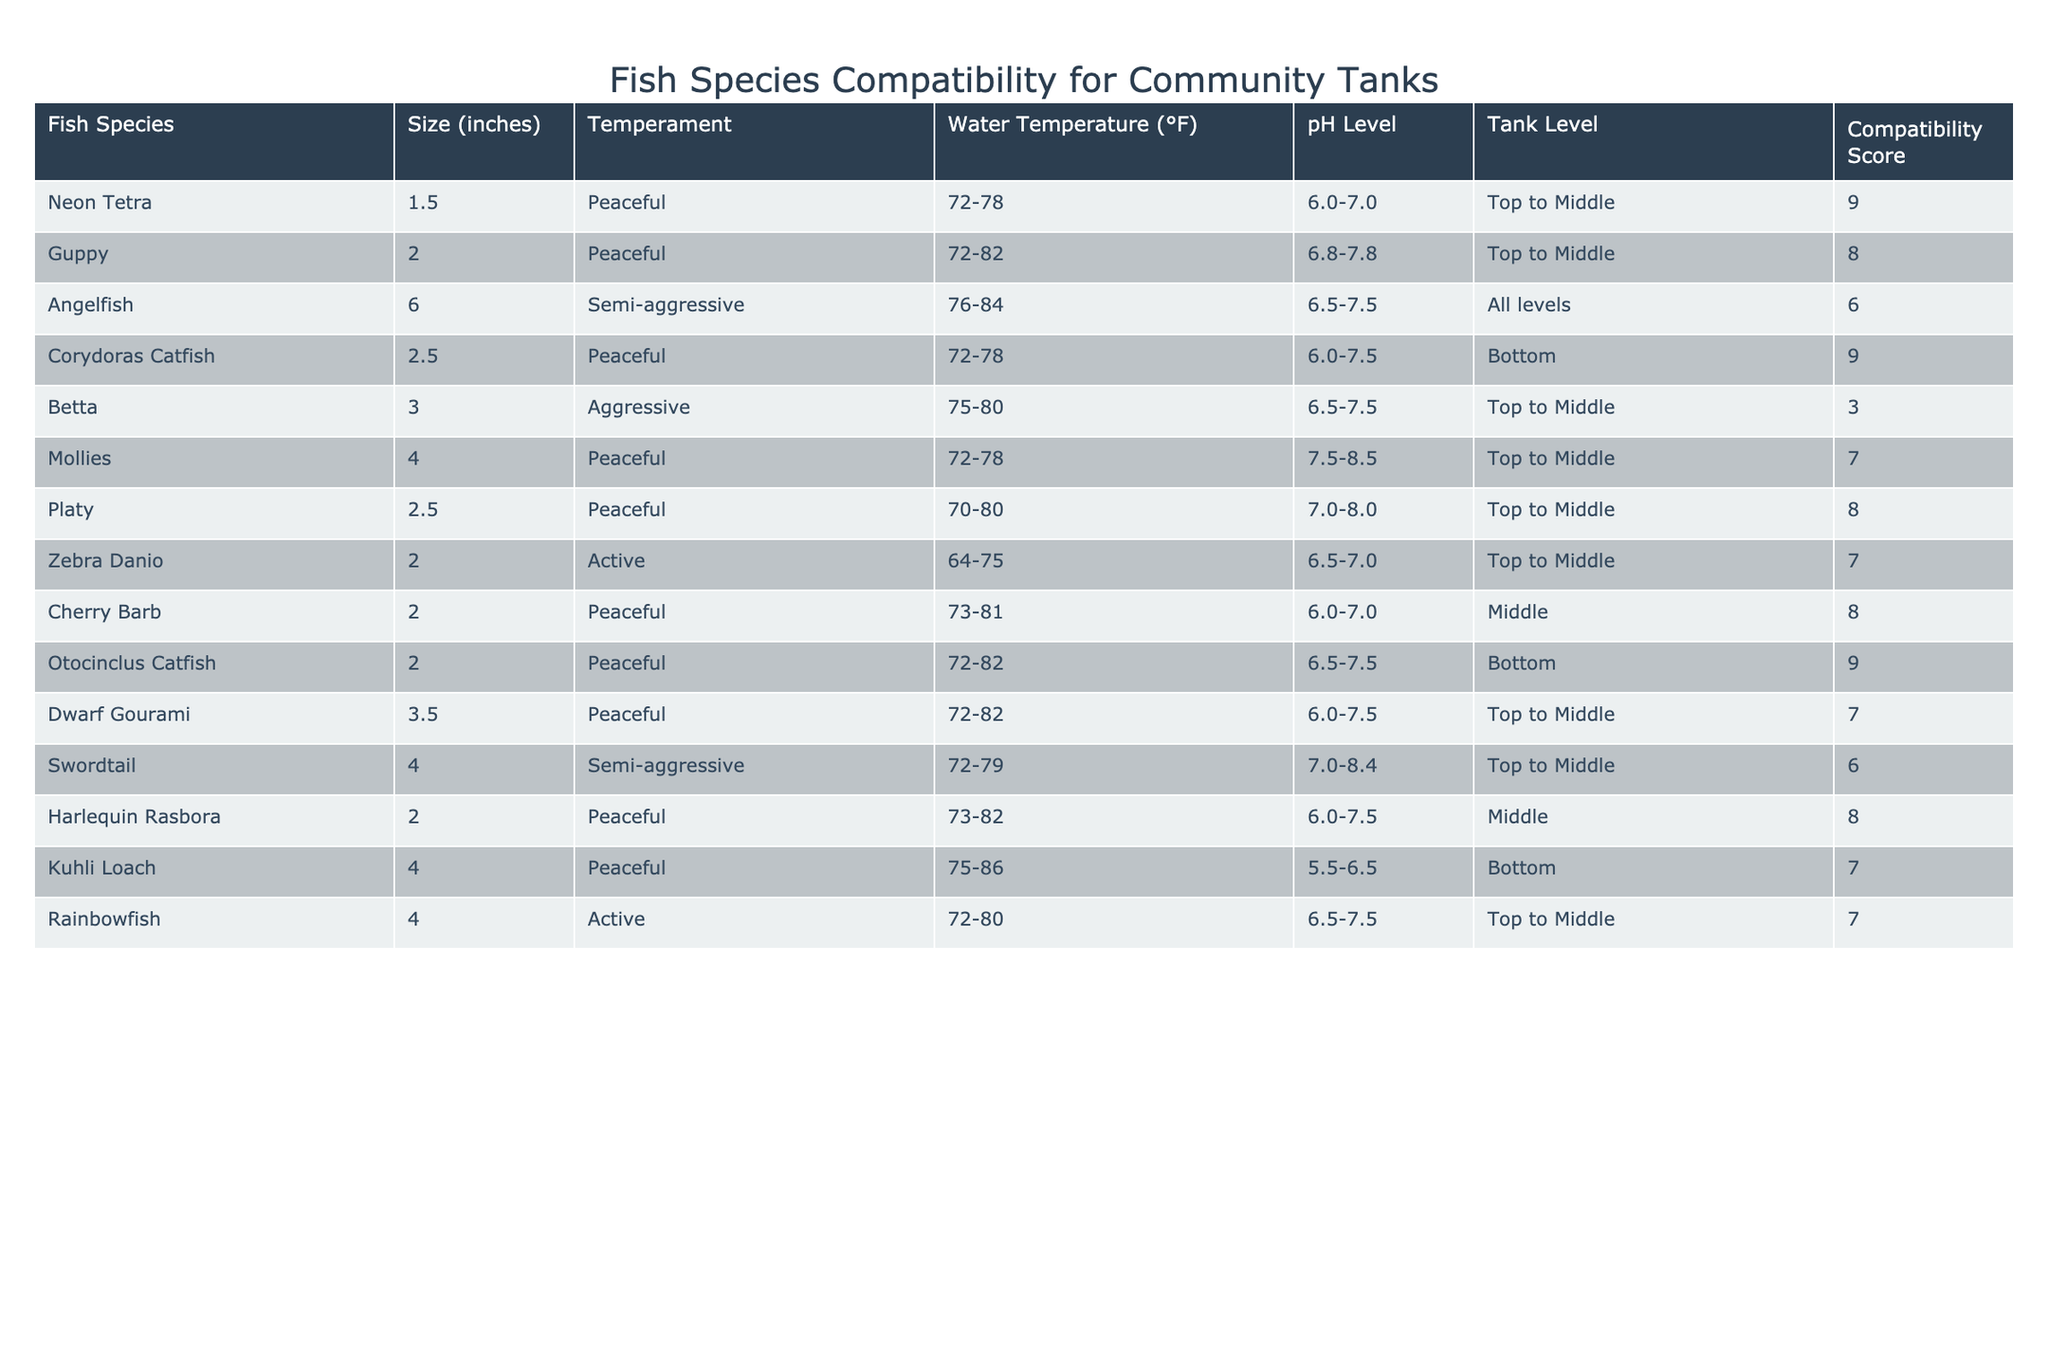What is the compatible fish species with the highest compatibility score? The compatibility scores indicate how well fish species can coexist in a community tank. By reviewing the table, we find that both the Neon Tetra and the Corydoras Catfish have a compatibility score of 9, which is the highest.
Answer: Neon Tetra and Corydoras Catfish Which fish species can tolerate the highest water temperature? Reviewing the water temperature range of each species, the Kuhli Loach can tolerate a maximum of 86°F, which is the highest of all species listed.
Answer: Kuhli Loach Are all fish species listed peaceful? By assessing the temperament column, not all species are peaceful. The Angelfish is semi-aggressive and the Betta is aggressive, confirming that there are fish with varying temperaments.
Answer: No What is the average size of the fish species listed? The sizes of the fish species are: 1.5, 2, 6, 2.5, 3, 4, 2.5, 2, 2, 4, 3.5, 4, and 4 inches. Adding these together gives 37.5 inches. There are 13 species, so the average size is 37.5/13, which is approximately 2.88 inches.
Answer: 2.88 inches Which peaceful fish species has the lowest compatibility score? Looking through the compatibility scores for peaceful fish species, the Betta, despite being labelled as peaceful, has a score of 3, which is the lowest among the peaceful category.
Answer: Betta How many fish species have a compatibility score of 7 or higher? By filtering the scores, we see the species with scores of 7 or higher are Neon Tetra, Guppy, Corydoras Catfish, Mollies, Platy, Cherry Barb, Harlequin Rasbora, and Kuhli Loach, totaling 8 species.
Answer: 8 species What is the range of pH levels for the angelfish? The pH level range for Angelfish is between 6.5 and 7.5, directly taken from the pH level column in the table.
Answer: 6.5-7.5 Do all the peaceful fish species occupy the same tank level? By checking the tank level column, the peaceful species occupy various levels: the Neon Tetra and Guppy are in the top to middle, Corydoras Catfish is at the bottom, and others fill different positions. This confirms that they do not all occupy the same level.
Answer: No 